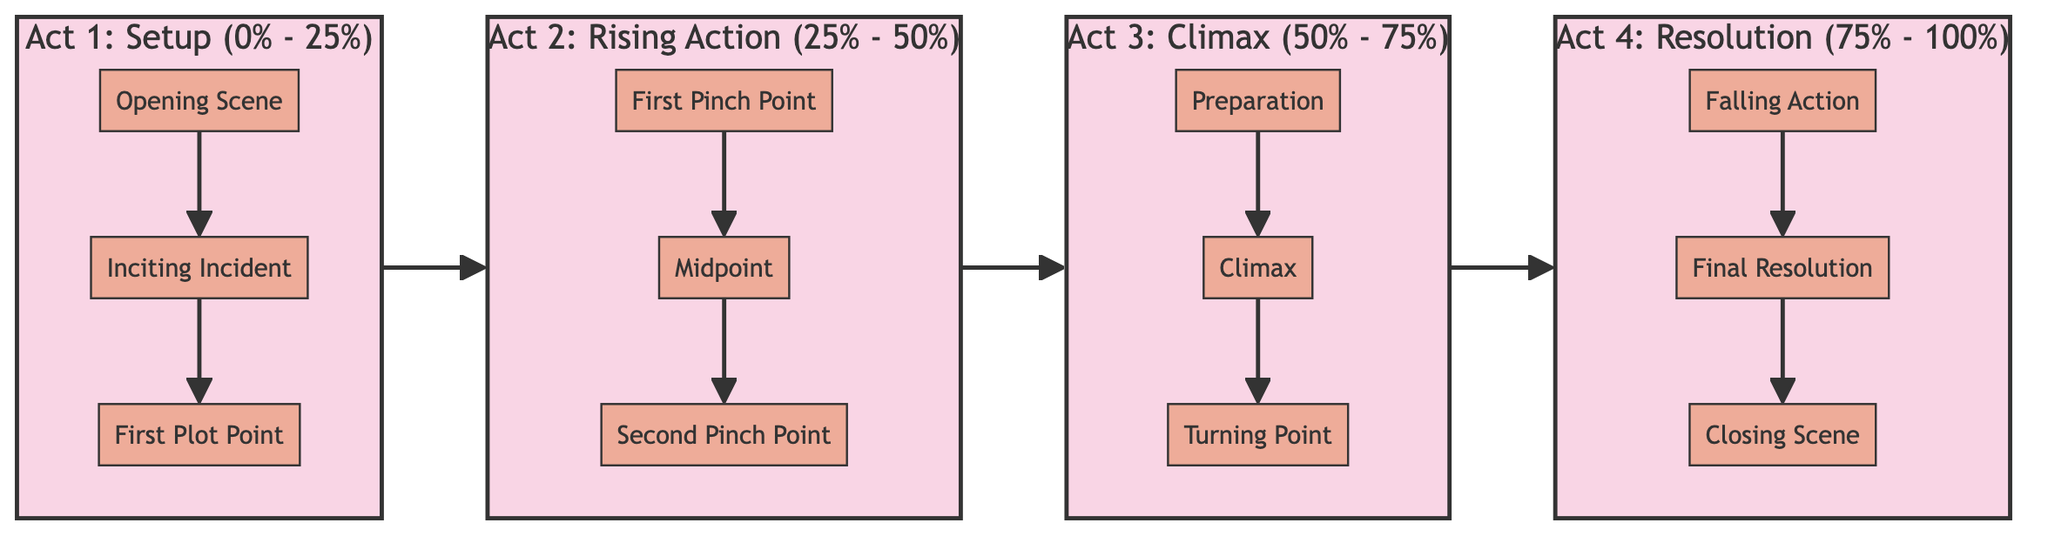What is the first plot point in Act 1? In Act 1, the diagram specifies that "First Plot Point" is the third element listed. Therefore, we find this title directly in the corresponding section of the diagram.
Answer: First Plot Point What percentage of the story structure does Act 2 cover? The diagram indicates that Act 2 spans from 25% to 50%, which means it covers a total of 25% of the story structure. This is observable from the labeled section that delineates the range for Act 2.
Answer: 25% How many total key plot points are shown in Act 3? In Act 3, there are three key plot points specifically labeled: "Preparation," "Climax," and "Turning Point." This can be counted directly from the diagram's section dedicated to Act 3.
Answer: 3 What connects the first plot point in Act 1 to the first pinch point in Act 2? The connection is made by the flow from Act 1 to Act 2 as shown in the diagram. The arrow leads from the third element of Act 1, "First Plot Point," directly to the first element of Act 2, "First Pinch Point," indicating a progression in the narrative structure.
Answer: Arrow What is the final event in Act 4? The final event listed in Act 4 is the "Closing Scene," which is the last point in the sequence of that act. This can be directly seen in the diagram under the section for Act 4.
Answer: Closing Scene What is the midpoint in Act 2? The midpoint of Act 2 is labeled "Midpoint" in the second section of the diagram. This is straightforward and can easily be located under the appropriate act in the flowchart.
Answer: Midpoint Which act contains the climax of the story? The climax is placed in Act 3. The diagram clearly indicates that "Climax" is the second key plot point in this act. This can be verified by examining the content listed under Act 3.
Answer: Act 3 How many acts are represented in this structure? The diagram shows a total of four acts, as indicated by the four labeled sections: Act 1, Act 2, Act 3, and Act 4. This information is visible in the overall structure of the diagram.
Answer: 4 